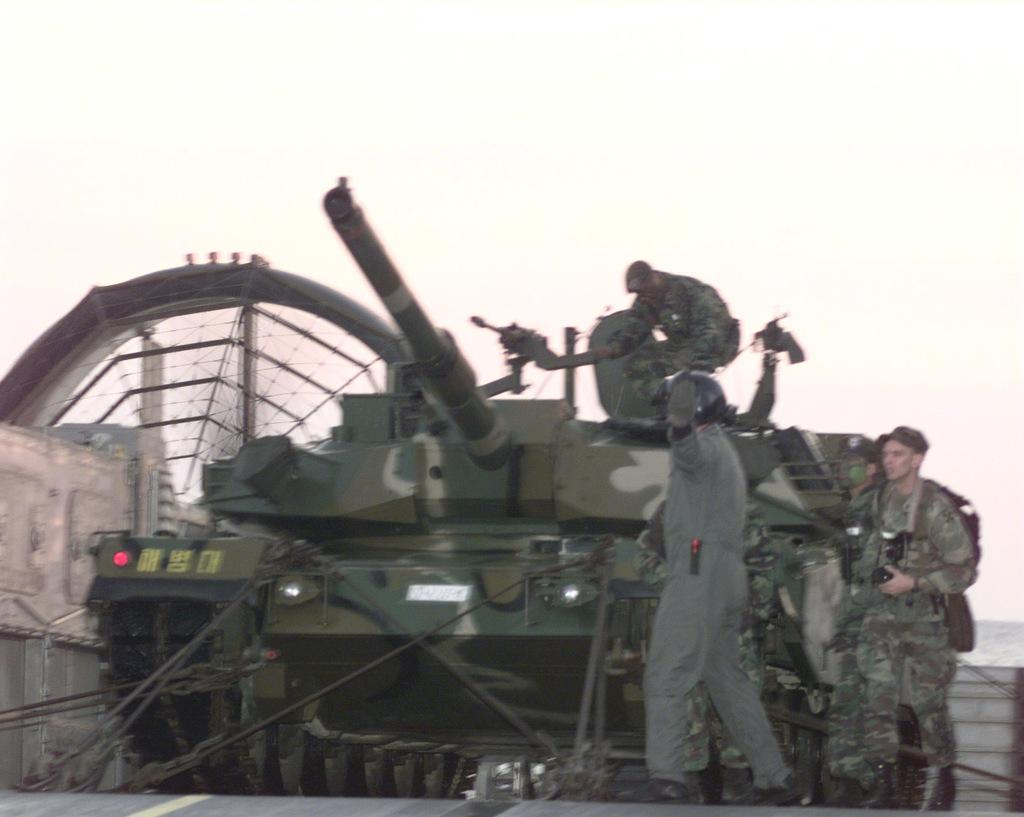What is the main subject in the image? There is a tanker in the image. Are there any other elements present in the image besides the tanker? Yes, there are people in the image. What type of representative can be seen in the bedroom alley in the image? There is no representative, bedroom, or alley present in the image. 